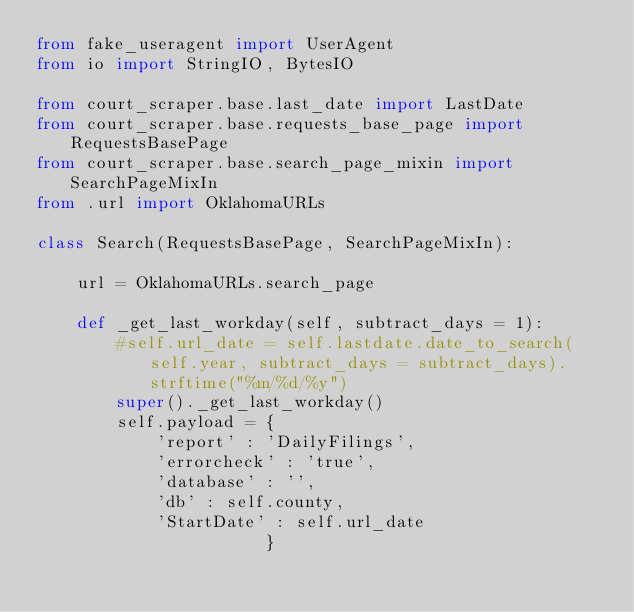Convert code to text. <code><loc_0><loc_0><loc_500><loc_500><_Python_>from fake_useragent import UserAgent
from io import StringIO, BytesIO

from court_scraper.base.last_date import LastDate
from court_scraper.base.requests_base_page import RequestsBasePage
from court_scraper.base.search_page_mixin import SearchPageMixIn
from .url import OklahomaURLs

class Search(RequestsBasePage, SearchPageMixIn):
    
    url = OklahomaURLs.search_page
        
    def _get_last_workday(self, subtract_days = 1):
        #self.url_date = self.lastdate.date_to_search(self.year, subtract_days = subtract_days).strftime("%m/%d/%y")
        super()._get_last_workday()
        self.payload = {
            'report' : 'DailyFilings',
            'errorcheck' : 'true',
            'database' : '',
            'db' : self.county,
            'StartDate' : self.url_date
                       }</code> 